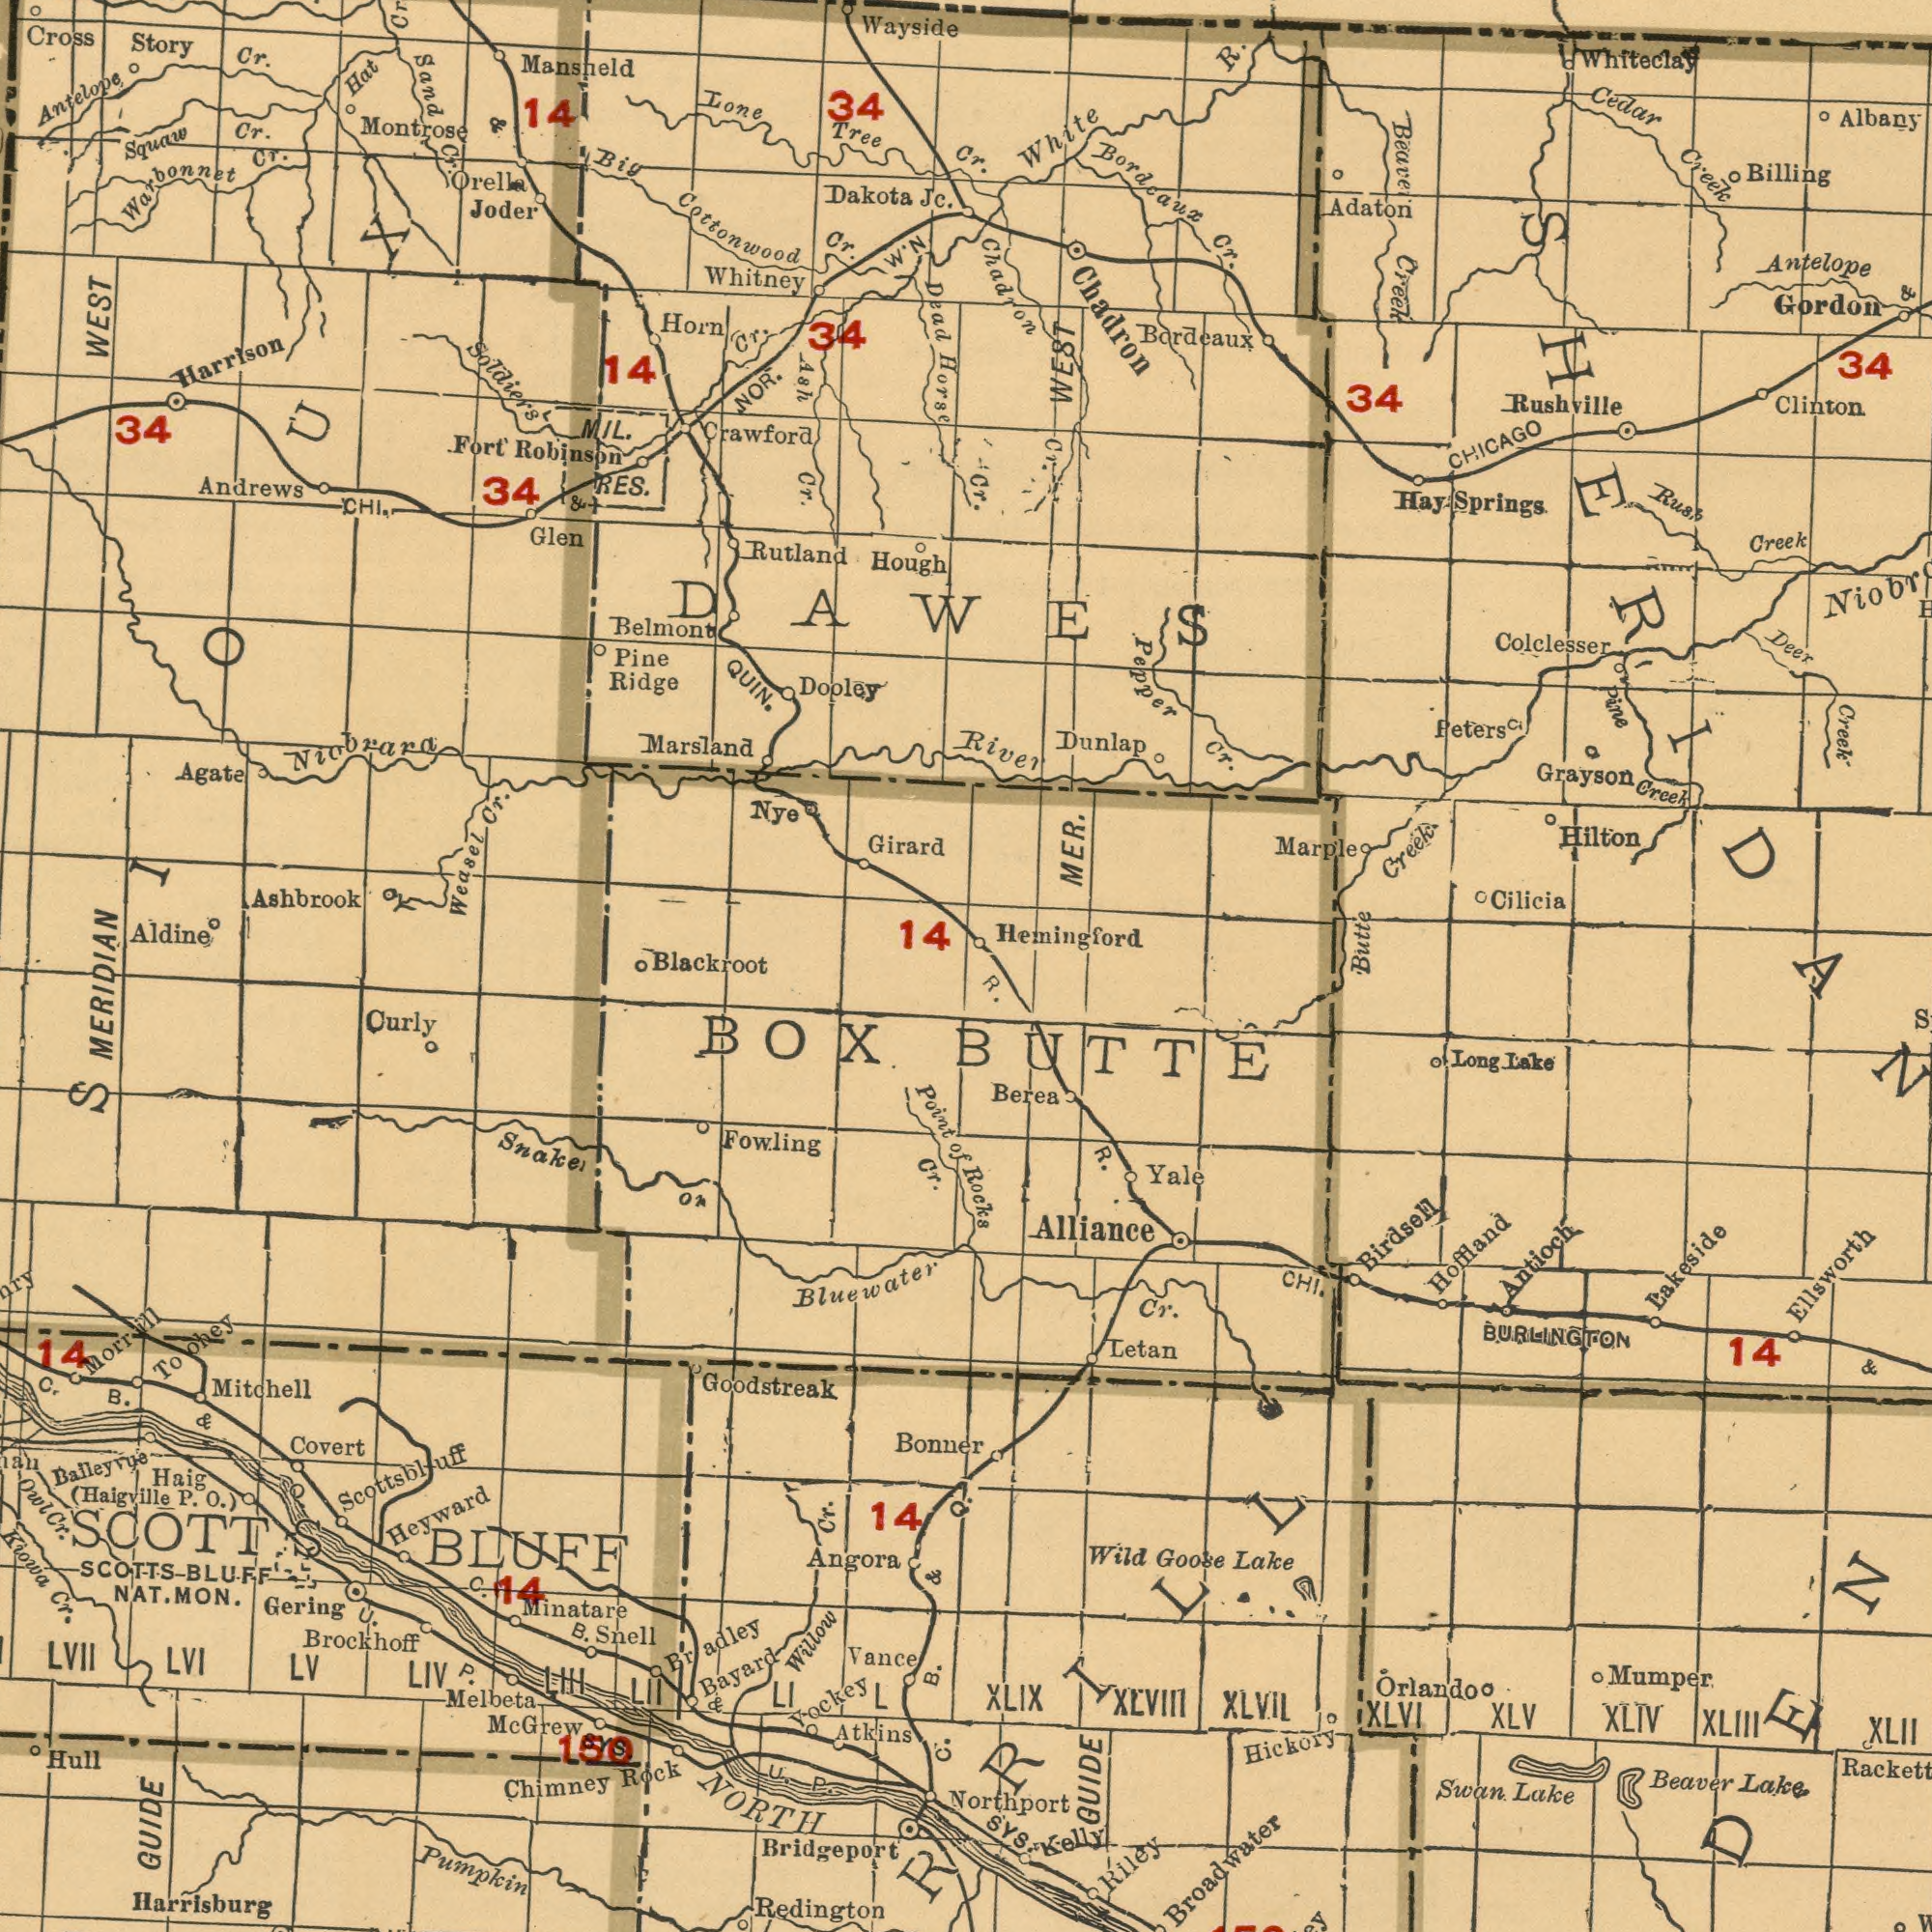What text is shown in the top-right quadrant? Bordcaux MER. Chadron Creek R. Creek Creek Gordon Colclesser White Cedar Billing Springs Grayson Dunlap Cilicia Rushville 34 Bordeaux River Hay Hilton Creek Albany Adaton Rush Peters Cr. Butte Creek Clinton Whiteclay 34 Creek Beaver WEST Chadron CHICAGO Pine Deer Cr. Antelope Pepper Hemingford Cr. Marple Cr. & Cr. What text can you see in the bottom-left section? Goodstreak NORTH BLUFF Redington Bridgeport Kiowa Bluewater MERIDIAN Cr. Chimney Rock Owl Haig Snaker Mitchell Atkins Fowling GUIDE Melbeta Heyward Vance SCOTT Brockhoff Balleyvue Cr SCOTTS LVII Yockey Minatare Covert Bayard Curly LVI NAT. Bonner B. U. LV Angora Cr. MON. (Haigville LIV 150 SneII Gering Willow B. BLUFF Morrill B. P. 14 C. C. Toohey Ian Pumpkin P. P. Harrisburg Hull BOX LI 14 of O.) & & L 14 Point LII LIII & Bradley Scottsbluff U. C. Mc Grew SYS. Cr. O. Q. What text is shown in the top-left quadrant? WEST Cottonwood Niobrara Cross Mansneld Ashbrook Tree Girard Warbonnet Harrison Robinson RES. Weasel Marsland Aldine Andrews Dakota Belmont Hat Joder Antelope Soldiers Sand Cr. Hough Rutland Wayside 34 Lone Glen Montrose Fort 34 Dooley Agate Dead Cr. Cr. Cr. Pine 34 NOR. Big Squaw Cr. Cr. Jc. Horn Ridge 34 MIL. Crawford Cr. DAWES Cr. Cr. Orella Story Whitney CHI. Ash QUIN. 14 Horse Blackroot 14 W'N Nye SIOUX & 14 & What text can you see in the bottom-right section? Broadwater Alliance Orlando XLV Hoffland Beaver Rackett Antioch R. R. Mumper XLIV Long Berea Lake Rocks Lake Lake XLII Letan XLIX Swan. XLVIII Birdsell XLIII GUIDE Lake Goose Hickory XLVIL Lakeside XLVI Cr. Riley 14 SYS. CHI. Kelly Wild Northport BURLINGTON & Ellsworth BUTTE Yale ###RRILL ###DEN 